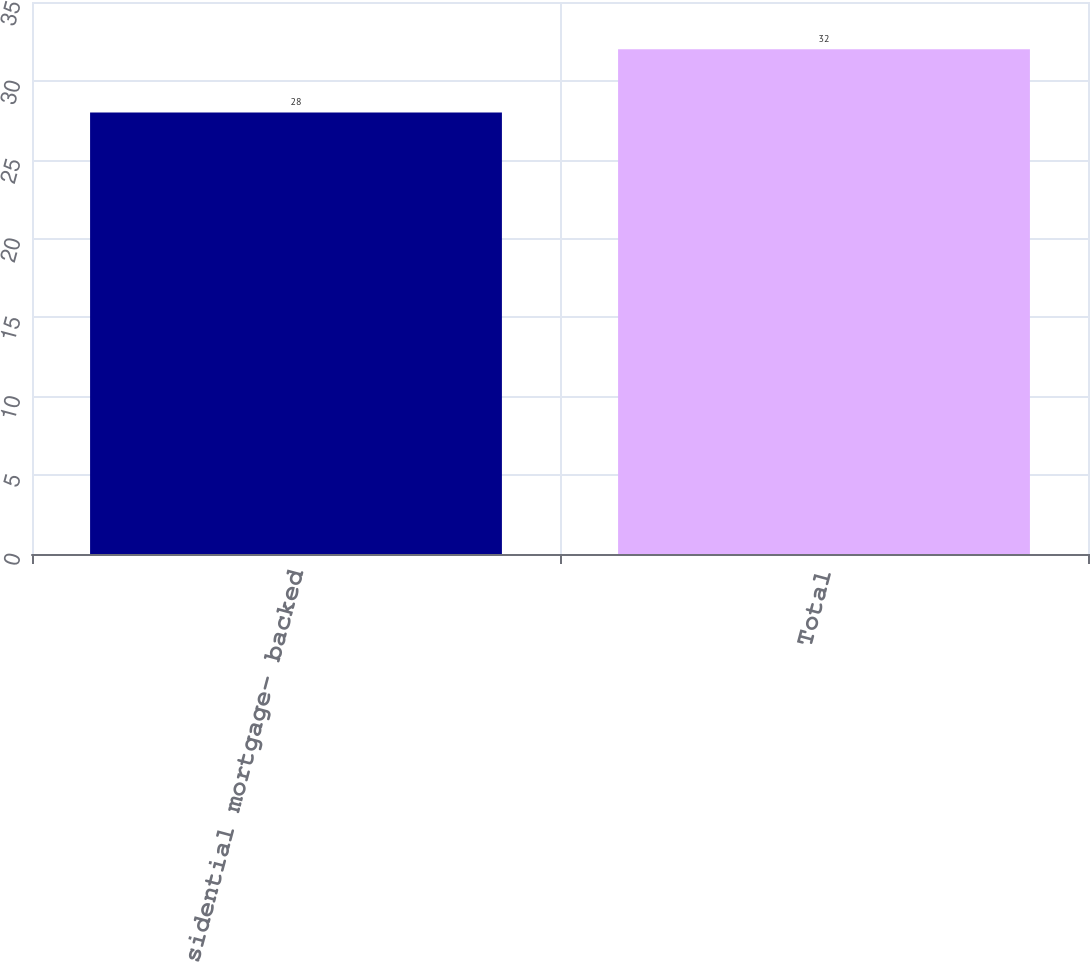<chart> <loc_0><loc_0><loc_500><loc_500><bar_chart><fcel>Residential mortgage- backed<fcel>Total<nl><fcel>28<fcel>32<nl></chart> 